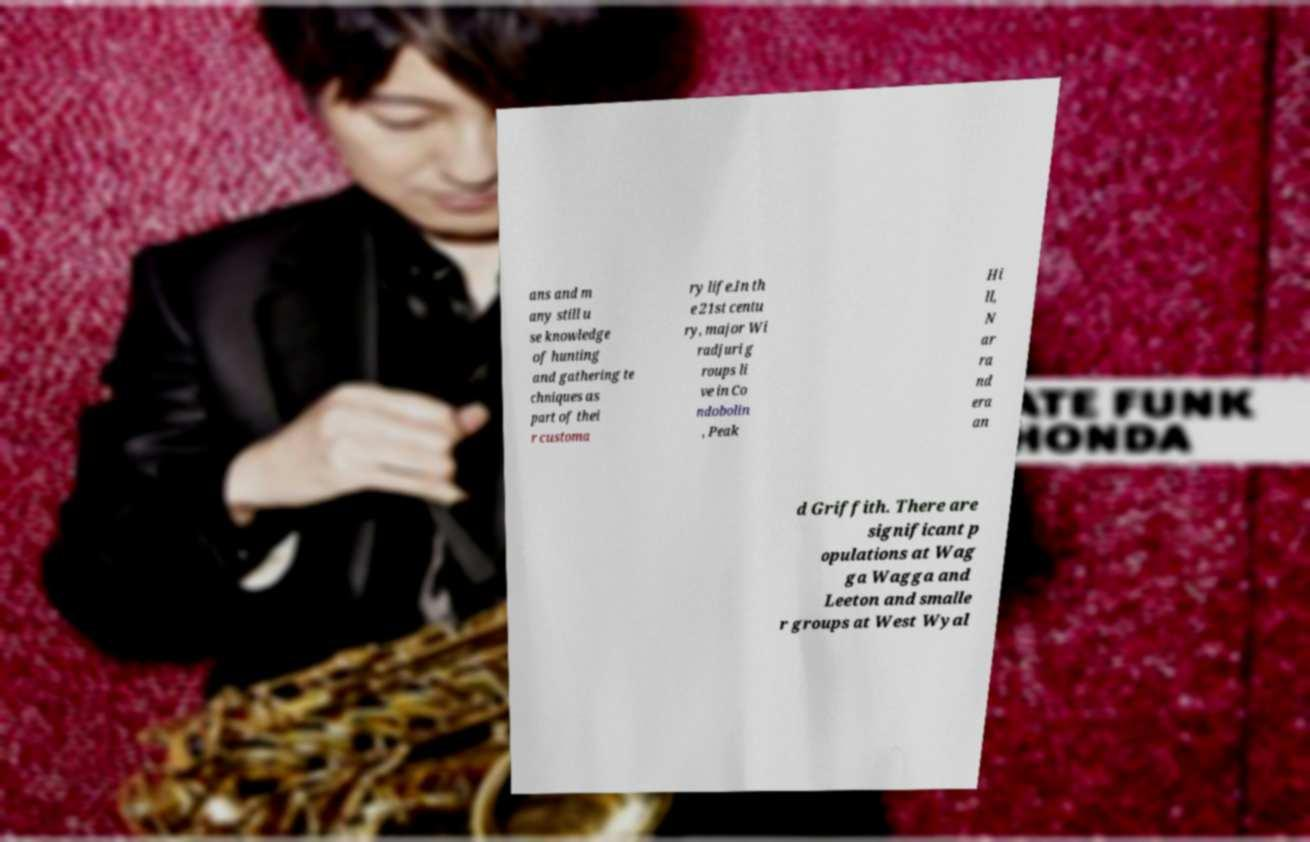What messages or text are displayed in this image? I need them in a readable, typed format. ans and m any still u se knowledge of hunting and gathering te chniques as part of thei r customa ry life.In th e 21st centu ry, major Wi radjuri g roups li ve in Co ndobolin , Peak Hi ll, N ar ra nd era an d Griffith. There are significant p opulations at Wag ga Wagga and Leeton and smalle r groups at West Wyal 